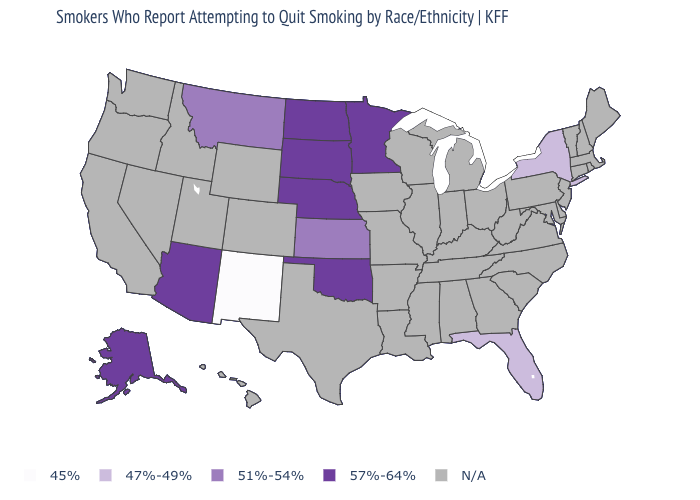What is the highest value in the USA?
Keep it brief. 57%-64%. Name the states that have a value in the range 45%?
Quick response, please. New Mexico. Which states hav the highest value in the MidWest?
Answer briefly. Minnesota, Nebraska, North Dakota, South Dakota. What is the value of New Jersey?
Short answer required. N/A. What is the highest value in the Northeast ?
Keep it brief. 47%-49%. Which states have the lowest value in the West?
Answer briefly. New Mexico. Name the states that have a value in the range 45%?
Answer briefly. New Mexico. What is the lowest value in the USA?
Quick response, please. 45%. Does South Dakota have the highest value in the USA?
Quick response, please. Yes. Name the states that have a value in the range 57%-64%?
Short answer required. Alaska, Arizona, Minnesota, Nebraska, North Dakota, Oklahoma, South Dakota. Name the states that have a value in the range 47%-49%?
Be succinct. Florida, New York. What is the highest value in the South ?
Answer briefly. 57%-64%. Does Kansas have the highest value in the USA?
Keep it brief. No. 